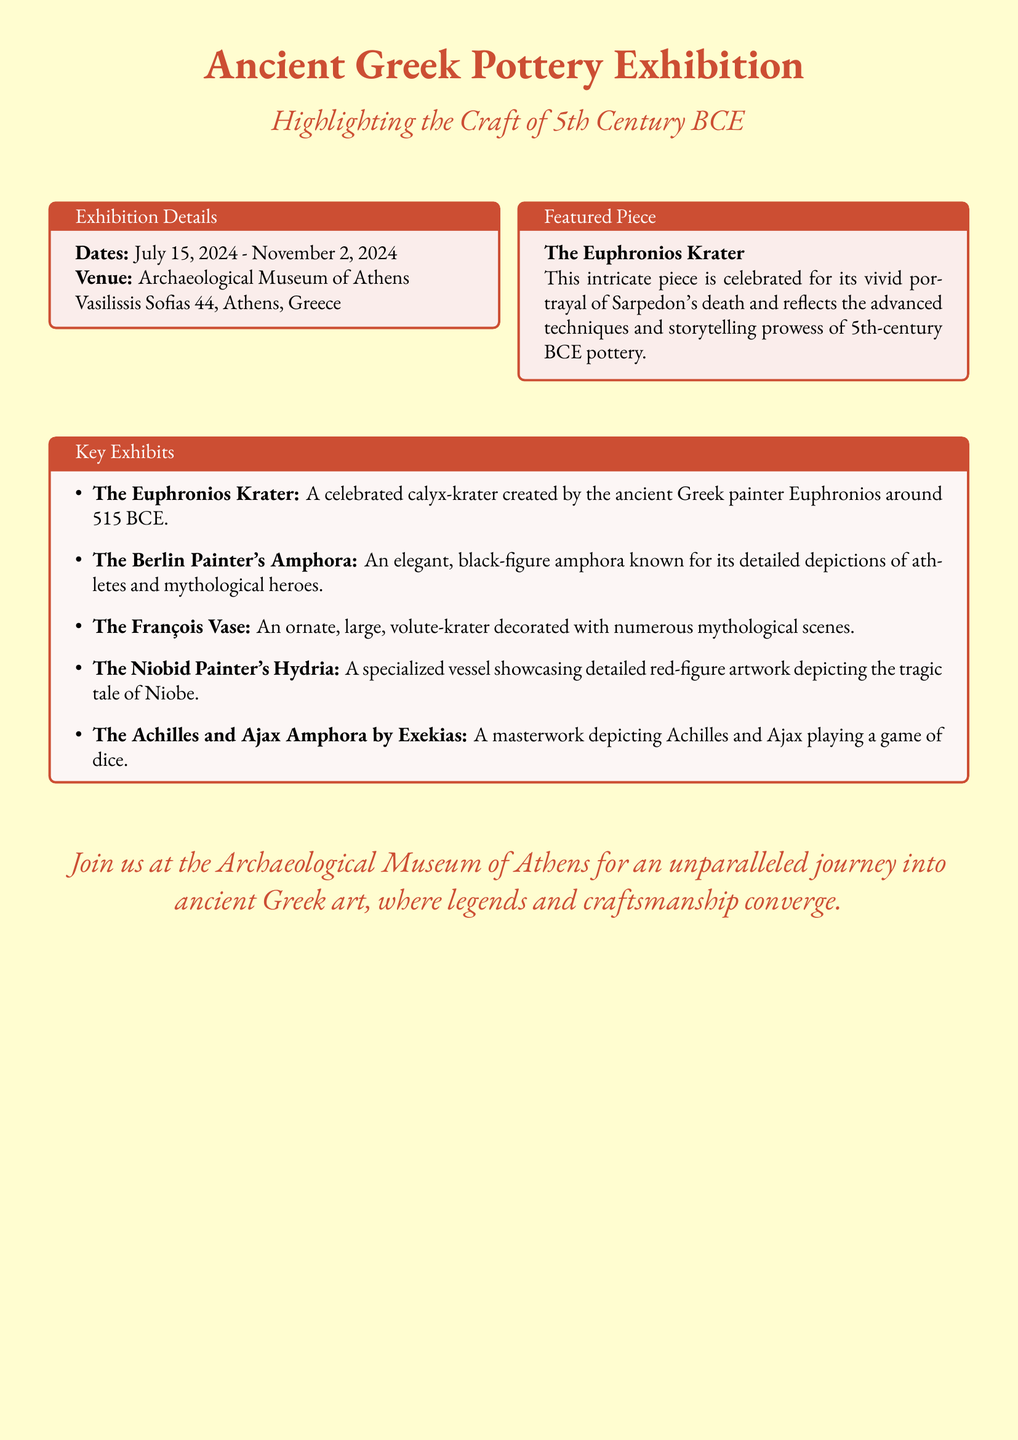What are the exhibition dates? The dates specified in the document are clearly listed in the exhibition details section.
Answer: July 15, 2024 - November 2, 2024 What is the venue for the exhibition? The venue is mentioned explicitly in the document under the exhibition details section.
Answer: Archaeological Museum of Athens What is the title of the featured pottery piece? The title of the featured piece is provided in its own tcolorbox within the document.
Answer: The Euphronios Krater Who created the Euphronios Krater? The document states that the Euphronios Krater was created by the ancient Greek painter Euphronios.
Answer: Euphronios Which piece depicts Achilles and Ajax? The document lists the key exhibits and specifies which piece features Achilles and Ajax.
Answer: The Achilles and Ajax Amphora by Exekias How many key exhibits are mentioned in total? The number of items in the key exhibits section can be counted directly from the list provided.
Answer: Five What theme do the key exhibits depict? The document categorizes the works of art and their themes related to Greek artistry, reflecting narrative scenes and characters from mythology.
Answer: Mythology What color scheme is used in the document? The document's aesthetic and color choices are indicated at the beginning, with specific colors named.
Answer: Terracotta and parchment 